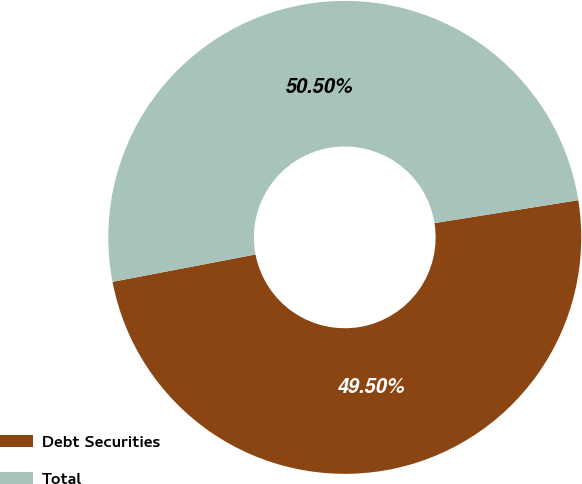Convert chart to OTSL. <chart><loc_0><loc_0><loc_500><loc_500><pie_chart><fcel>Debt Securities<fcel>Total<nl><fcel>49.5%<fcel>50.5%<nl></chart> 